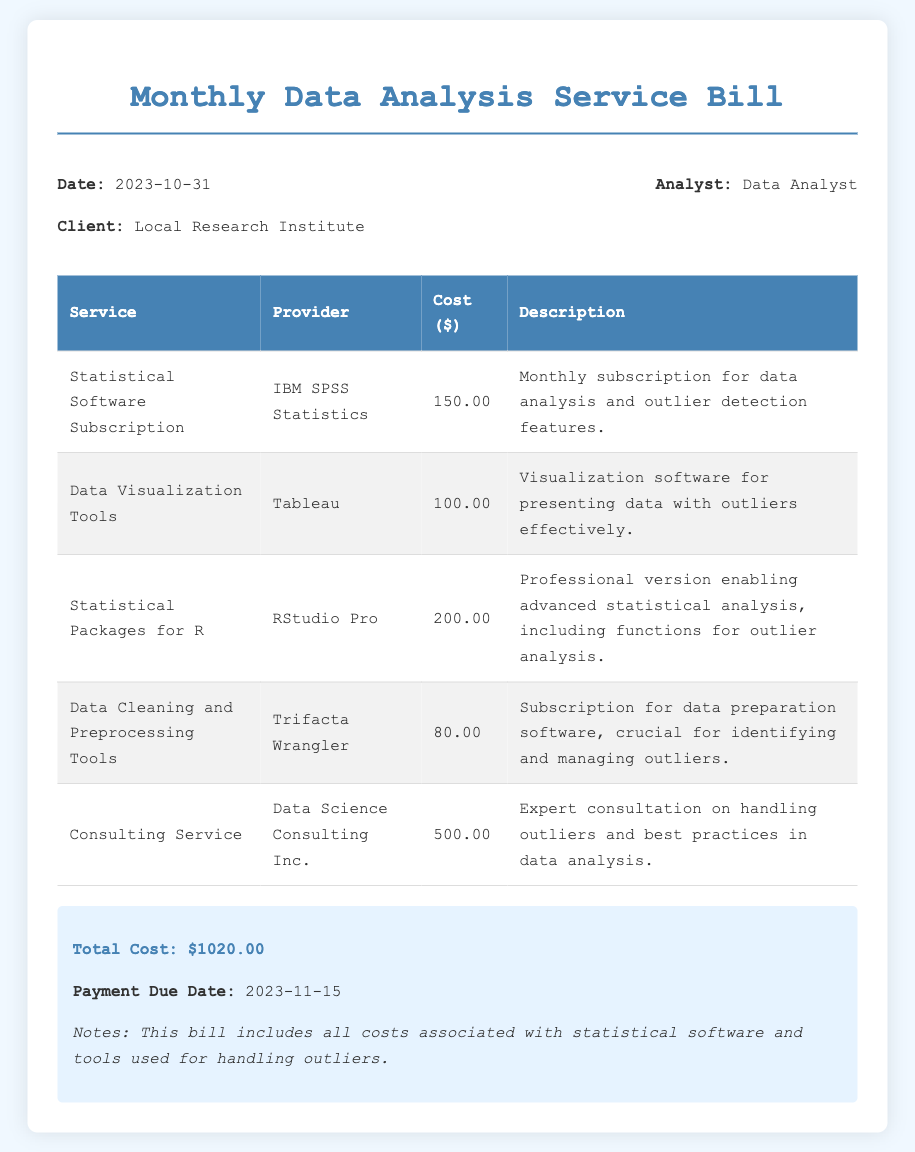What is the date of the bill? The date of the bill is explicitly mentioned in the header information section.
Answer: 2023-10-31 Who is the client for this bill? The client is identified in the header information section as the recipient of the services.
Answer: Local Research Institute What is the total cost of the services rendered? The total cost is noted in the summary section of the bill.
Answer: $1020.00 Which statistical software subscription is listed in the bill? The bill details the services, including their corresponding providers and descriptions.
Answer: IBM SPSS Statistics What type of consulting service is included in the bill? The bill provides specific details on the consulting service offered, focusing on its expertise.
Answer: Expert consultation on handling outliers and best practices in data analysis How much does the subscription for Data Cleaning and Preprocessing Tools cost? The cost for that service is detailed in the table of services.
Answer: $80.00 What is the payment due date? The payment due date is specified in the summary section at the bottom of the document.
Answer: 2023-11-15 Which tool is used for presenting data with outliers? The description in the table specifies the purpose of this particular tool.
Answer: Tableau What service provides advanced statistical analysis functions? Each service in the bill includes a short description of its main capabilities.
Answer: RStudio Pro 